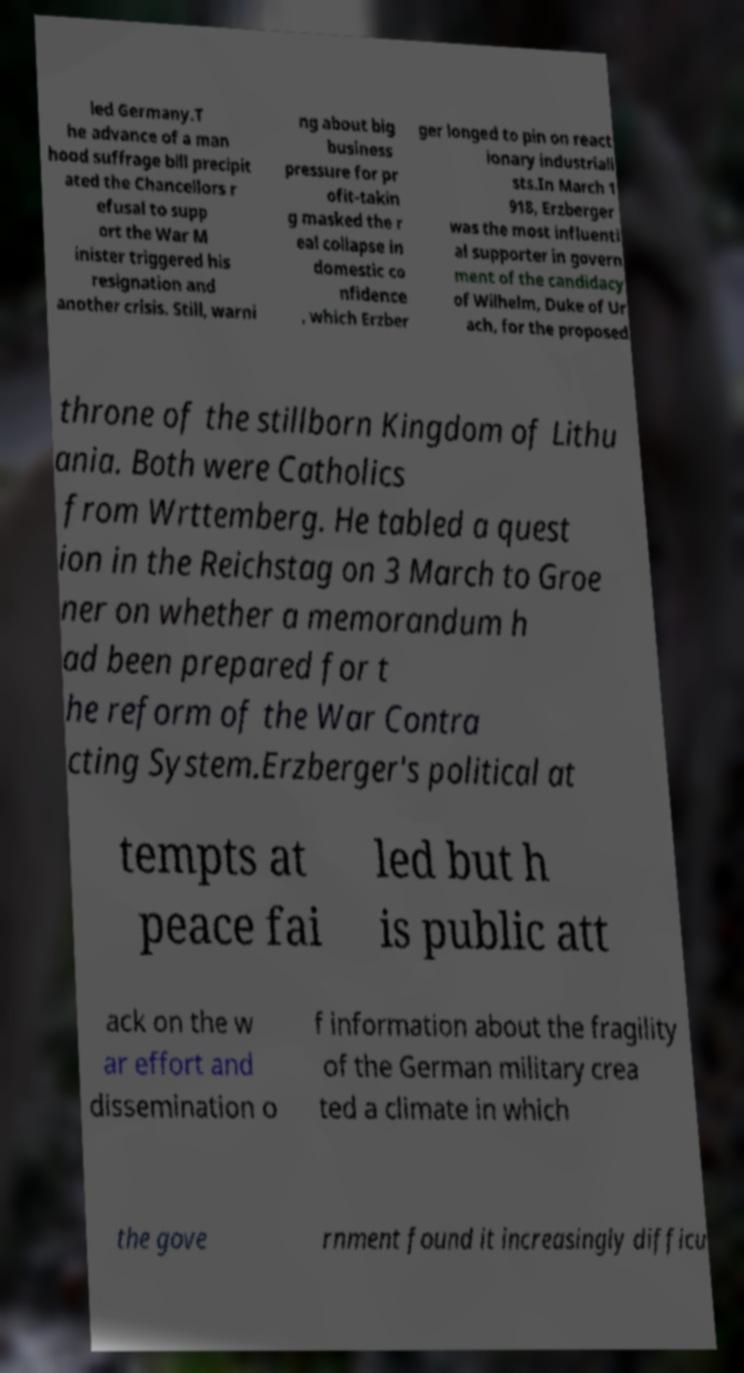Could you extract and type out the text from this image? led Germany.T he advance of a man hood suffrage bill precipit ated the Chancellors r efusal to supp ort the War M inister triggered his resignation and another crisis. Still, warni ng about big business pressure for pr ofit-takin g masked the r eal collapse in domestic co nfidence , which Erzber ger longed to pin on react ionary industriali sts.In March 1 918, Erzberger was the most influenti al supporter in govern ment of the candidacy of Wilhelm, Duke of Ur ach, for the proposed throne of the stillborn Kingdom of Lithu ania. Both were Catholics from Wrttemberg. He tabled a quest ion in the Reichstag on 3 March to Groe ner on whether a memorandum h ad been prepared for t he reform of the War Contra cting System.Erzberger's political at tempts at peace fai led but h is public att ack on the w ar effort and dissemination o f information about the fragility of the German military crea ted a climate in which the gove rnment found it increasingly difficu 